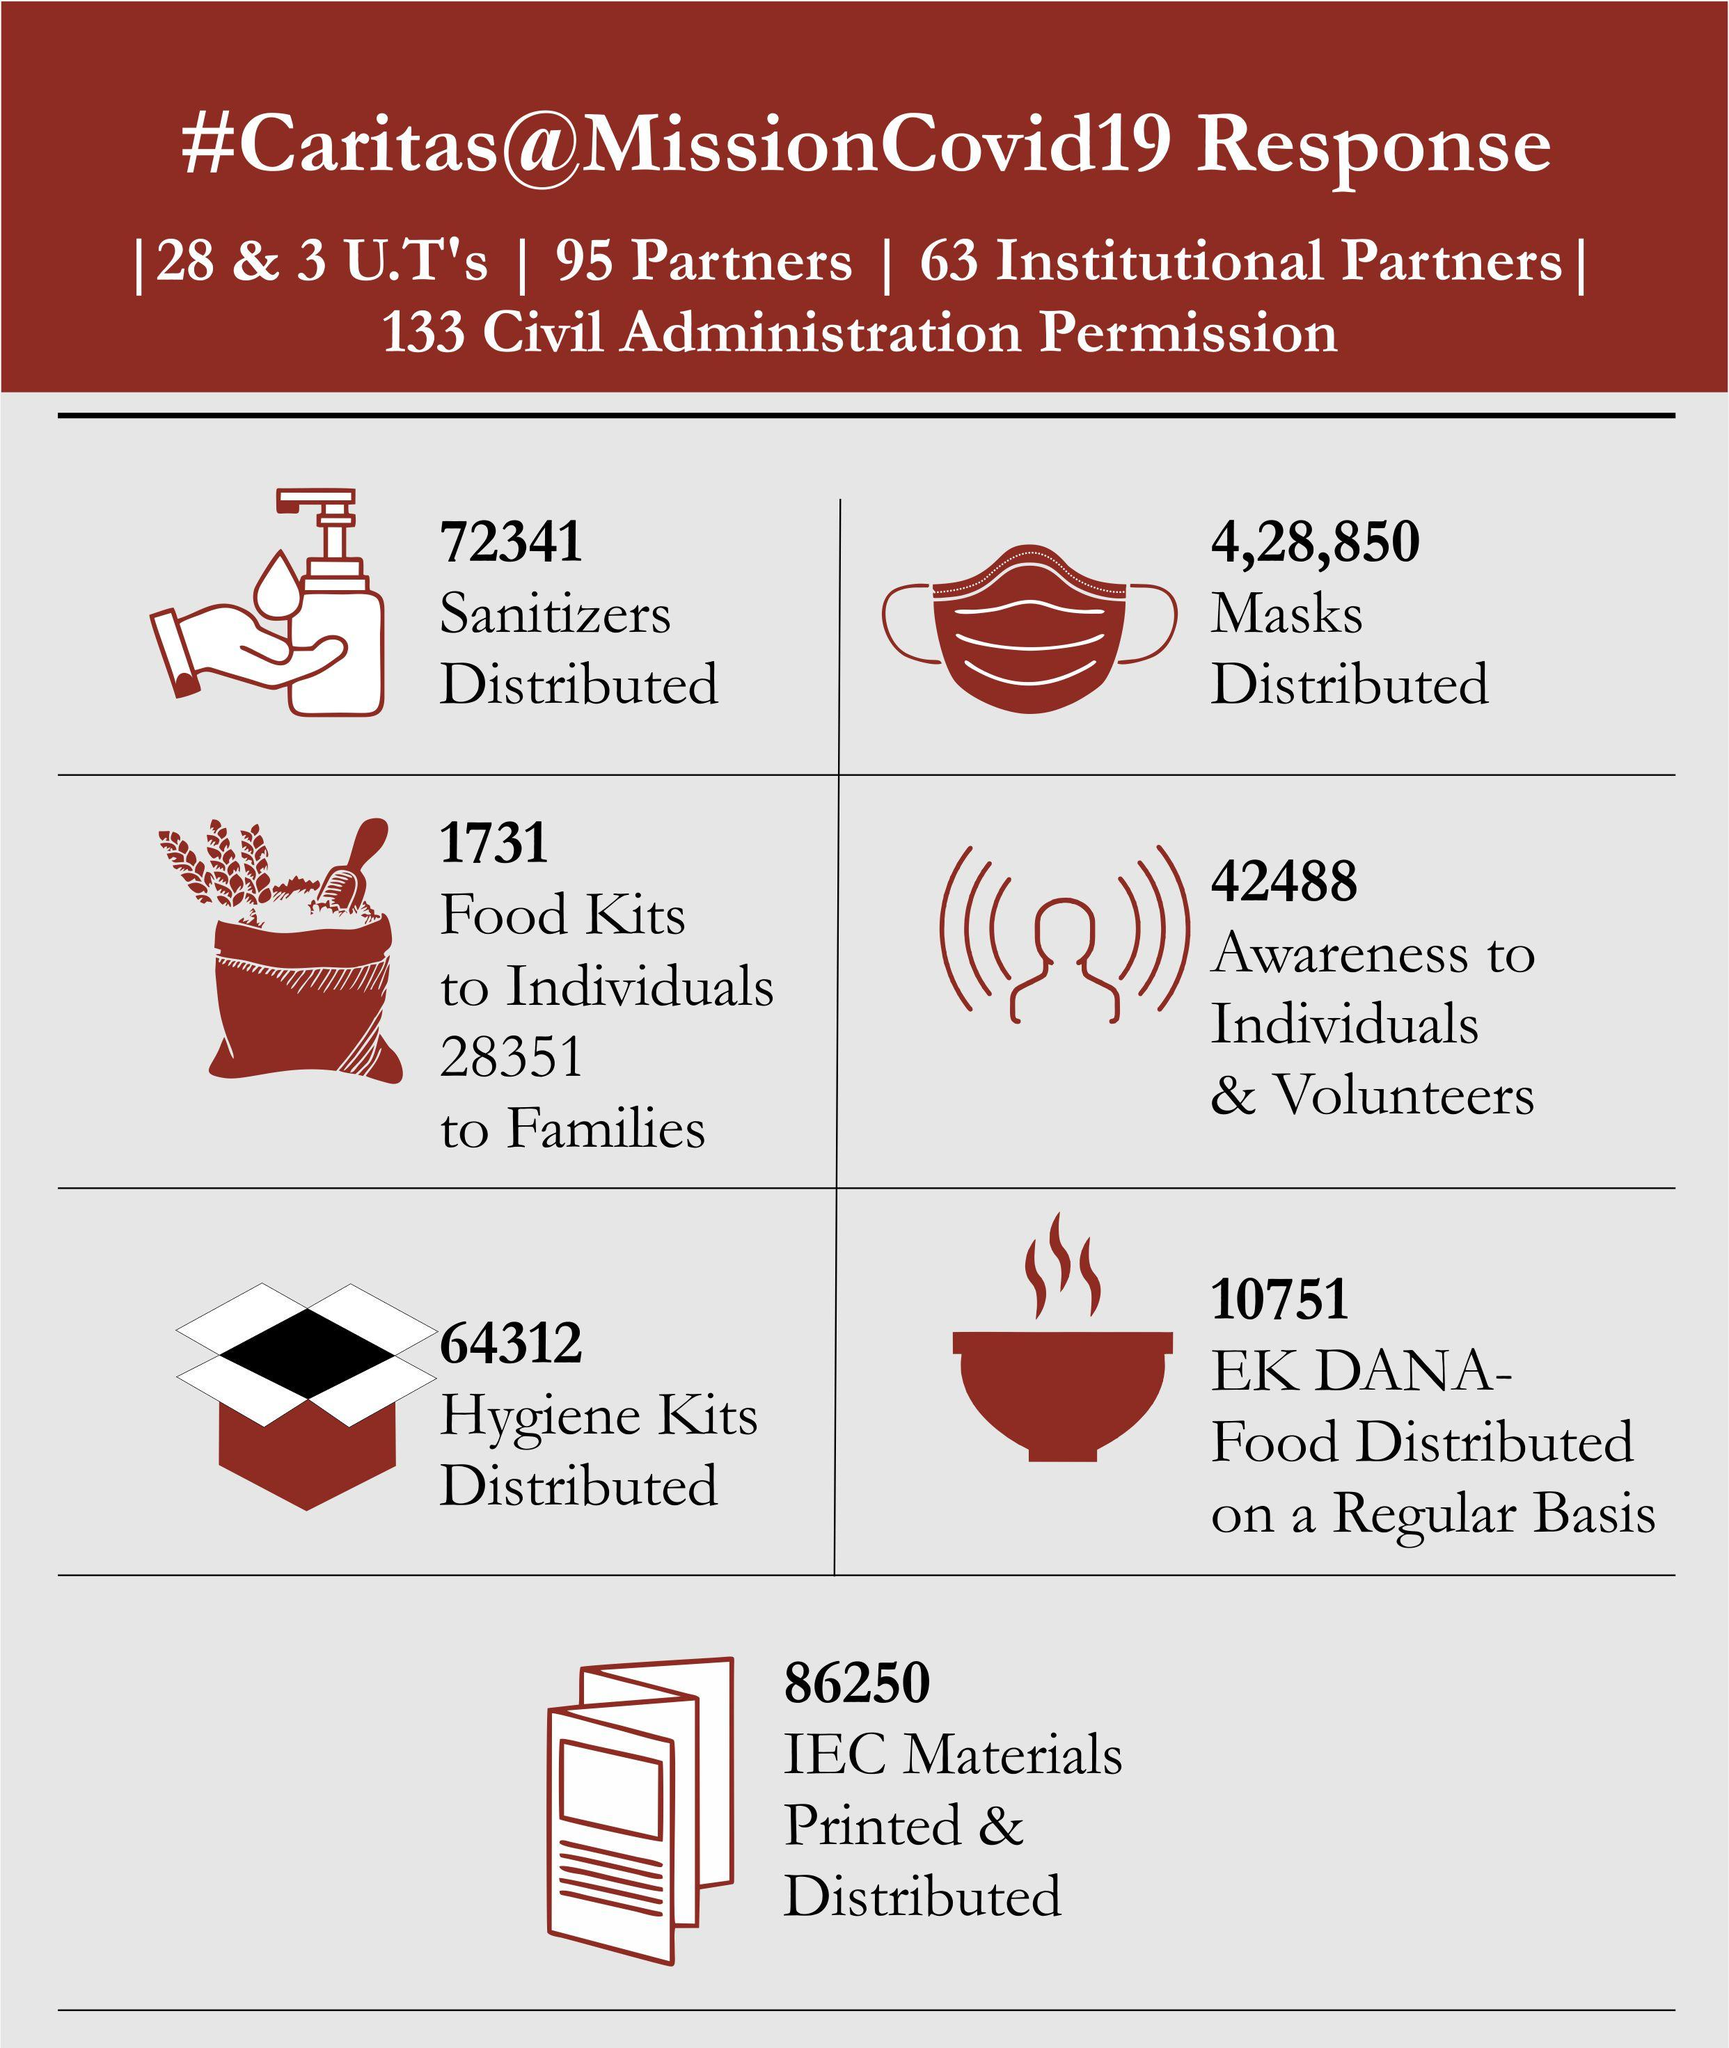Point out several critical features in this image. In total, 5,01,191 sanitizers and masks were distributed to combat the COVID-19 pandemic in India. During the response period, a total of 30,082 food kits were distributed to both individuals and families. 